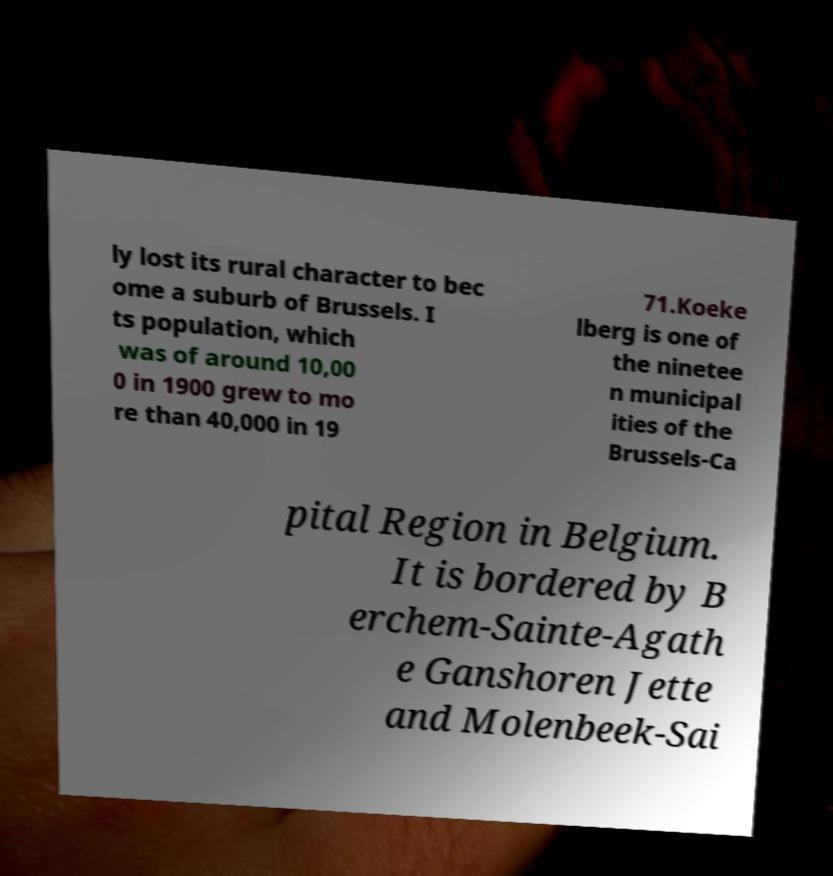Please identify and transcribe the text found in this image. ly lost its rural character to bec ome a suburb of Brussels. I ts population, which was of around 10,00 0 in 1900 grew to mo re than 40,000 in 19 71.Koeke lberg is one of the ninetee n municipal ities of the Brussels-Ca pital Region in Belgium. It is bordered by B erchem-Sainte-Agath e Ganshoren Jette and Molenbeek-Sai 